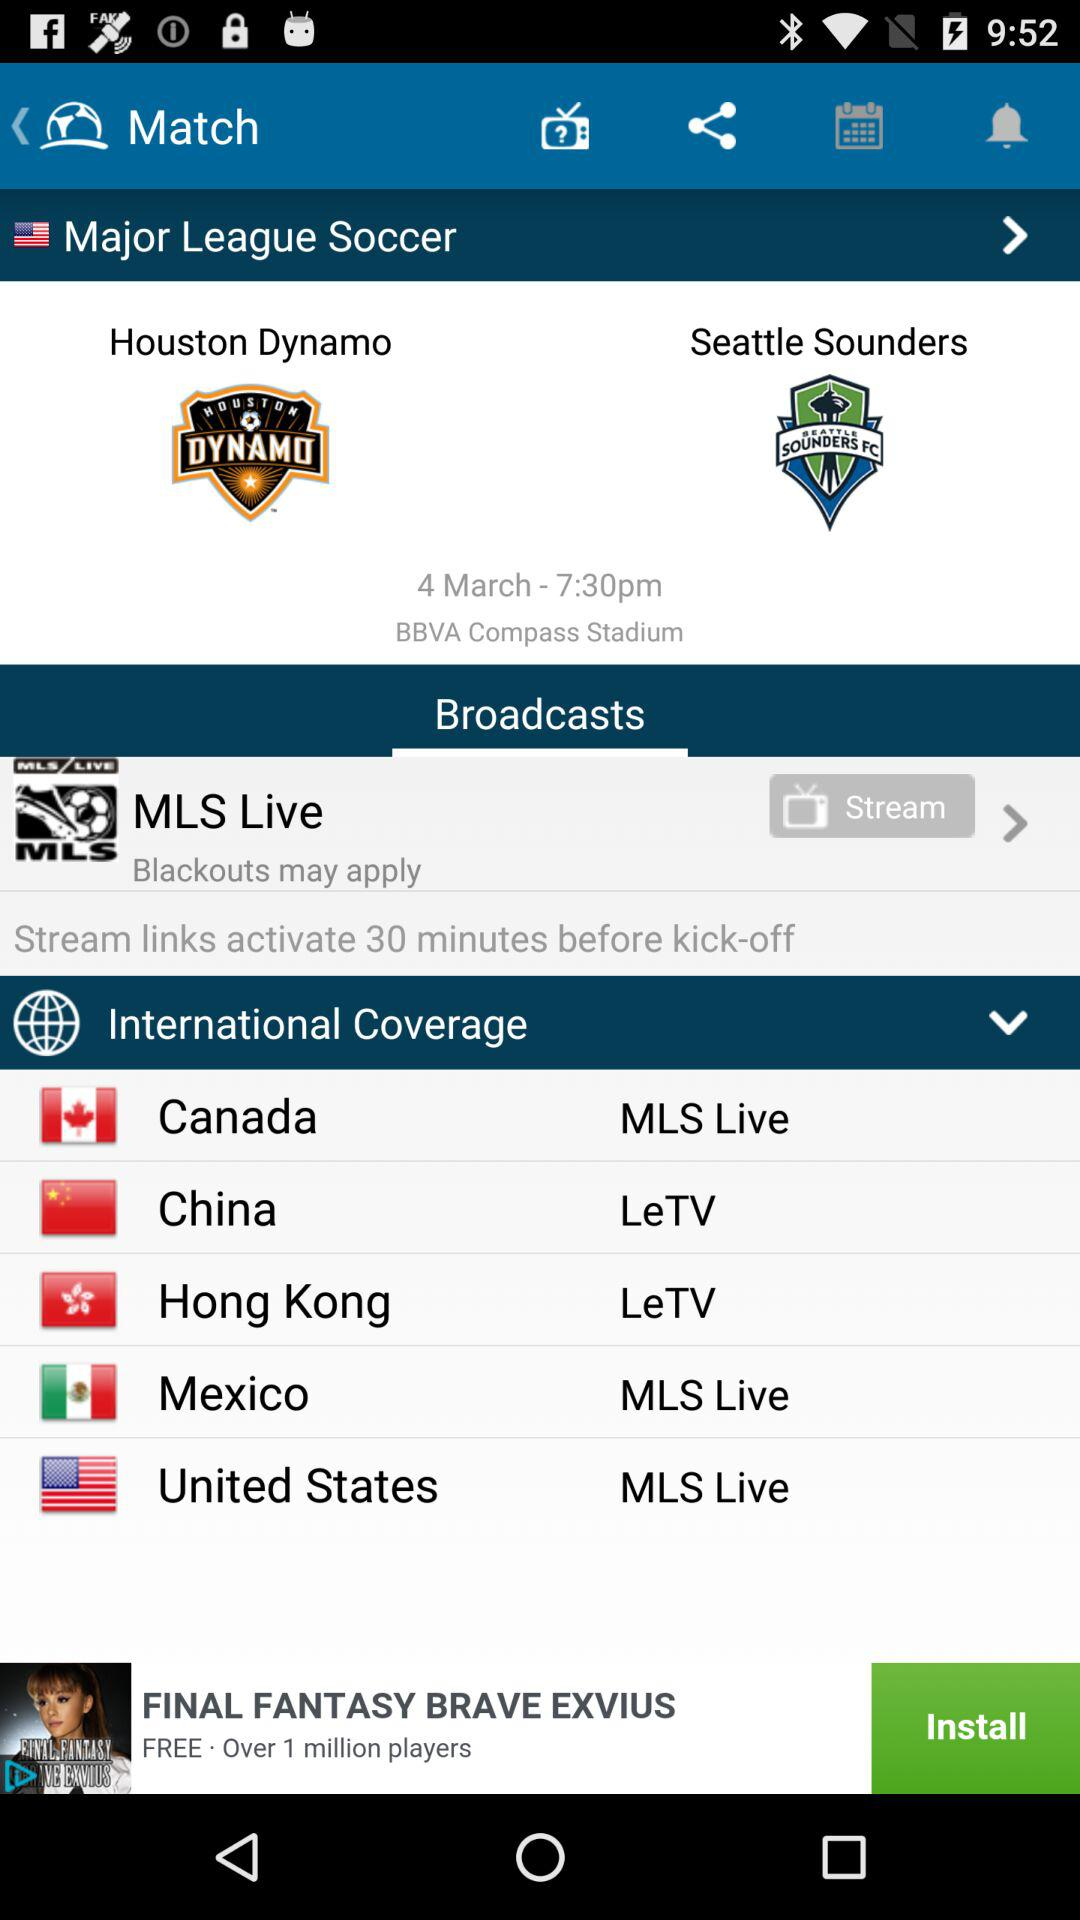What is the match time? The match time is 7:30 p.m. 